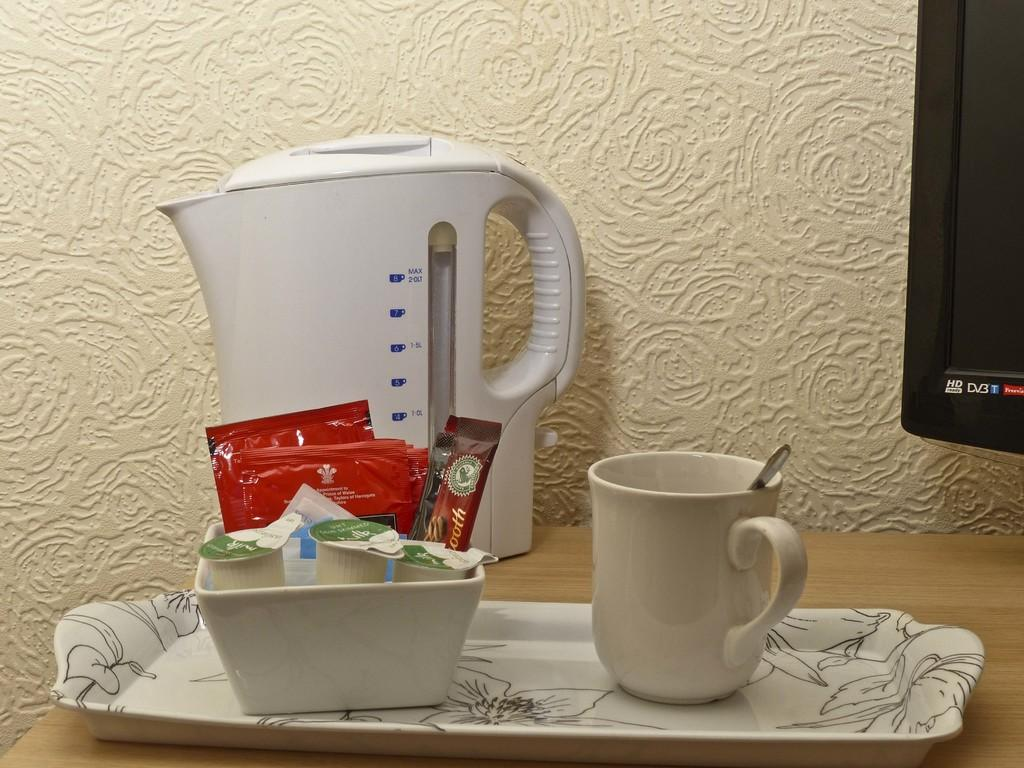<image>
Share a concise interpretation of the image provided. An HD Ready TV is to the right of a tea making set on a wooden dresser. 